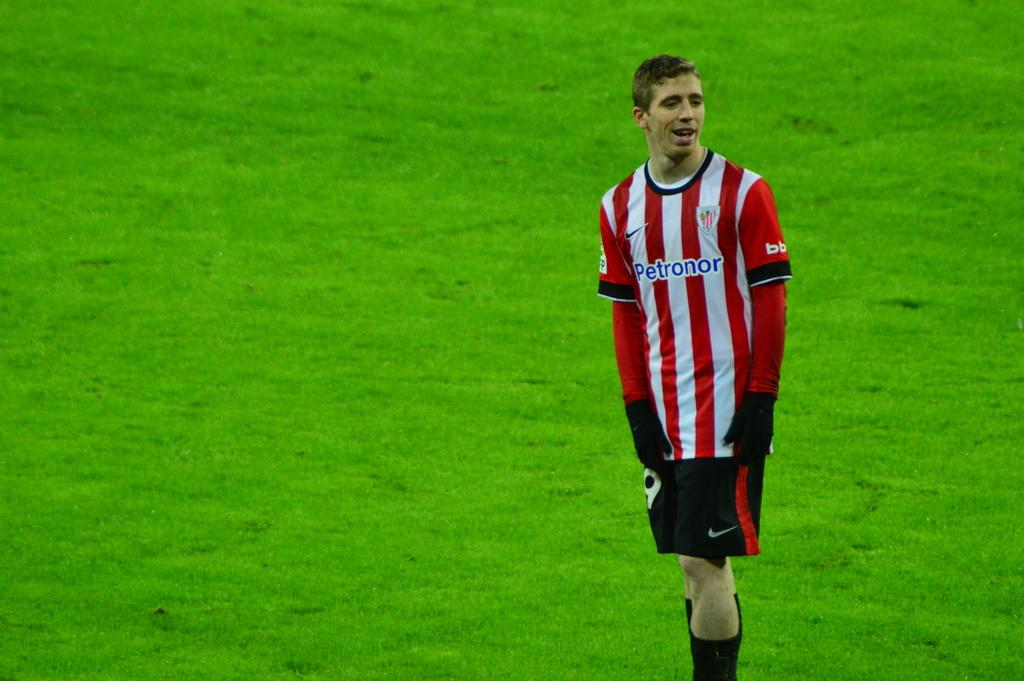Provide a one-sentence caption for the provided image. a person wearing a jersey that has the word petronor on it. 